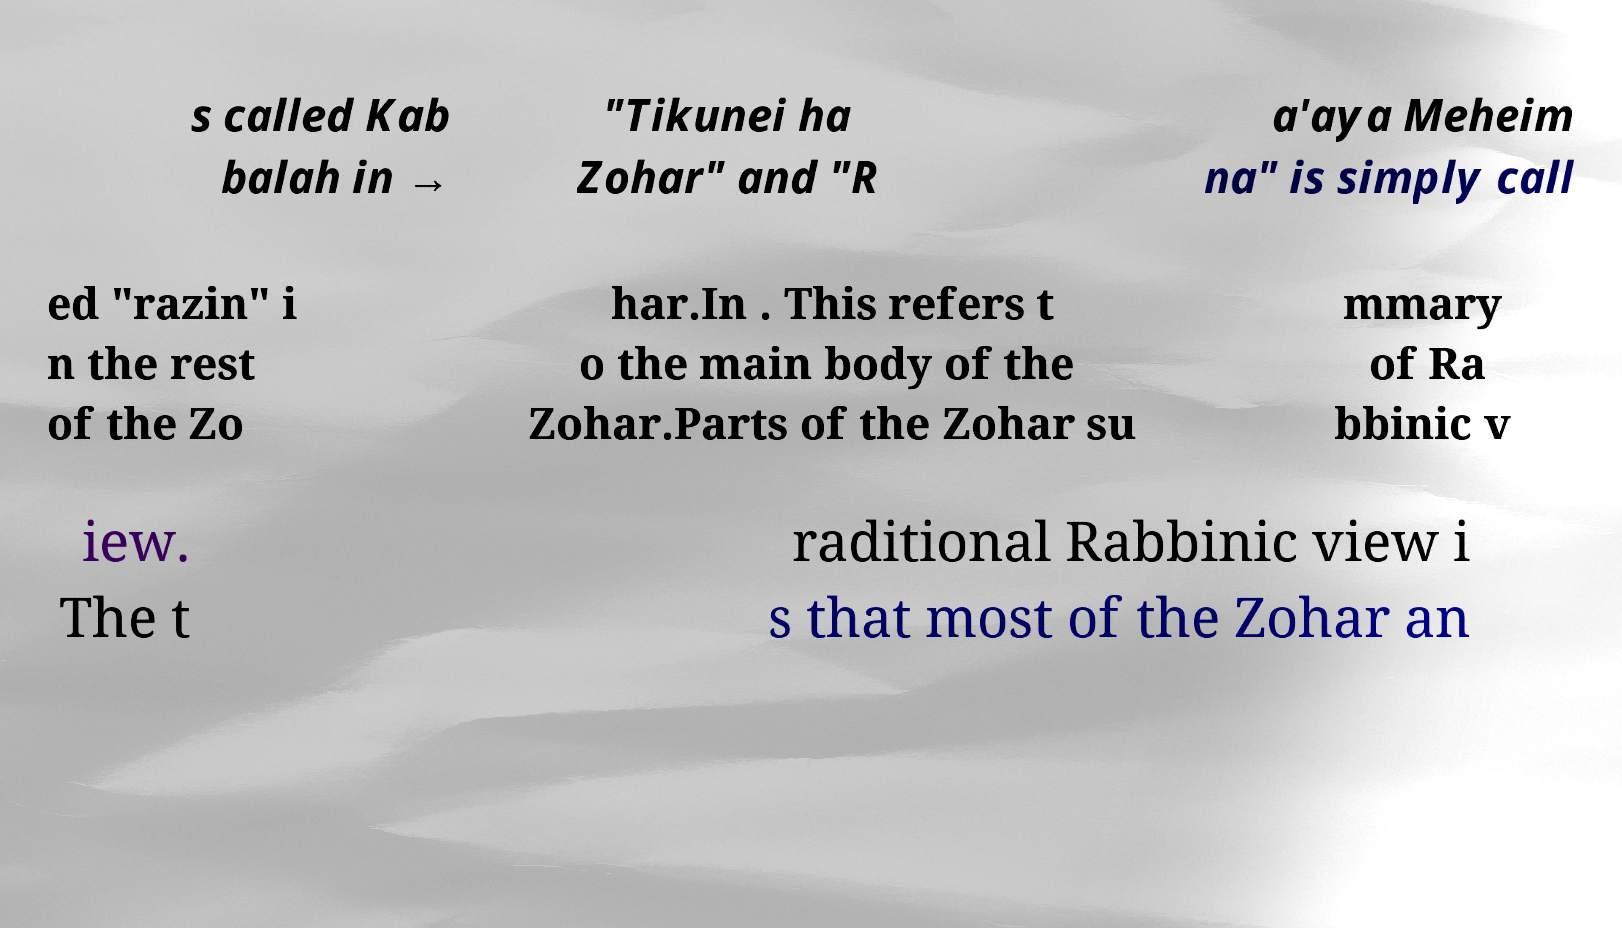Could you assist in decoding the text presented in this image and type it out clearly? s called Kab balah in → "Tikunei ha Zohar" and "R a'aya Meheim na" is simply call ed "razin" i n the rest of the Zo har.In . This refers t o the main body of the Zohar.Parts of the Zohar su mmary of Ra bbinic v iew. The t raditional Rabbinic view i s that most of the Zohar an 